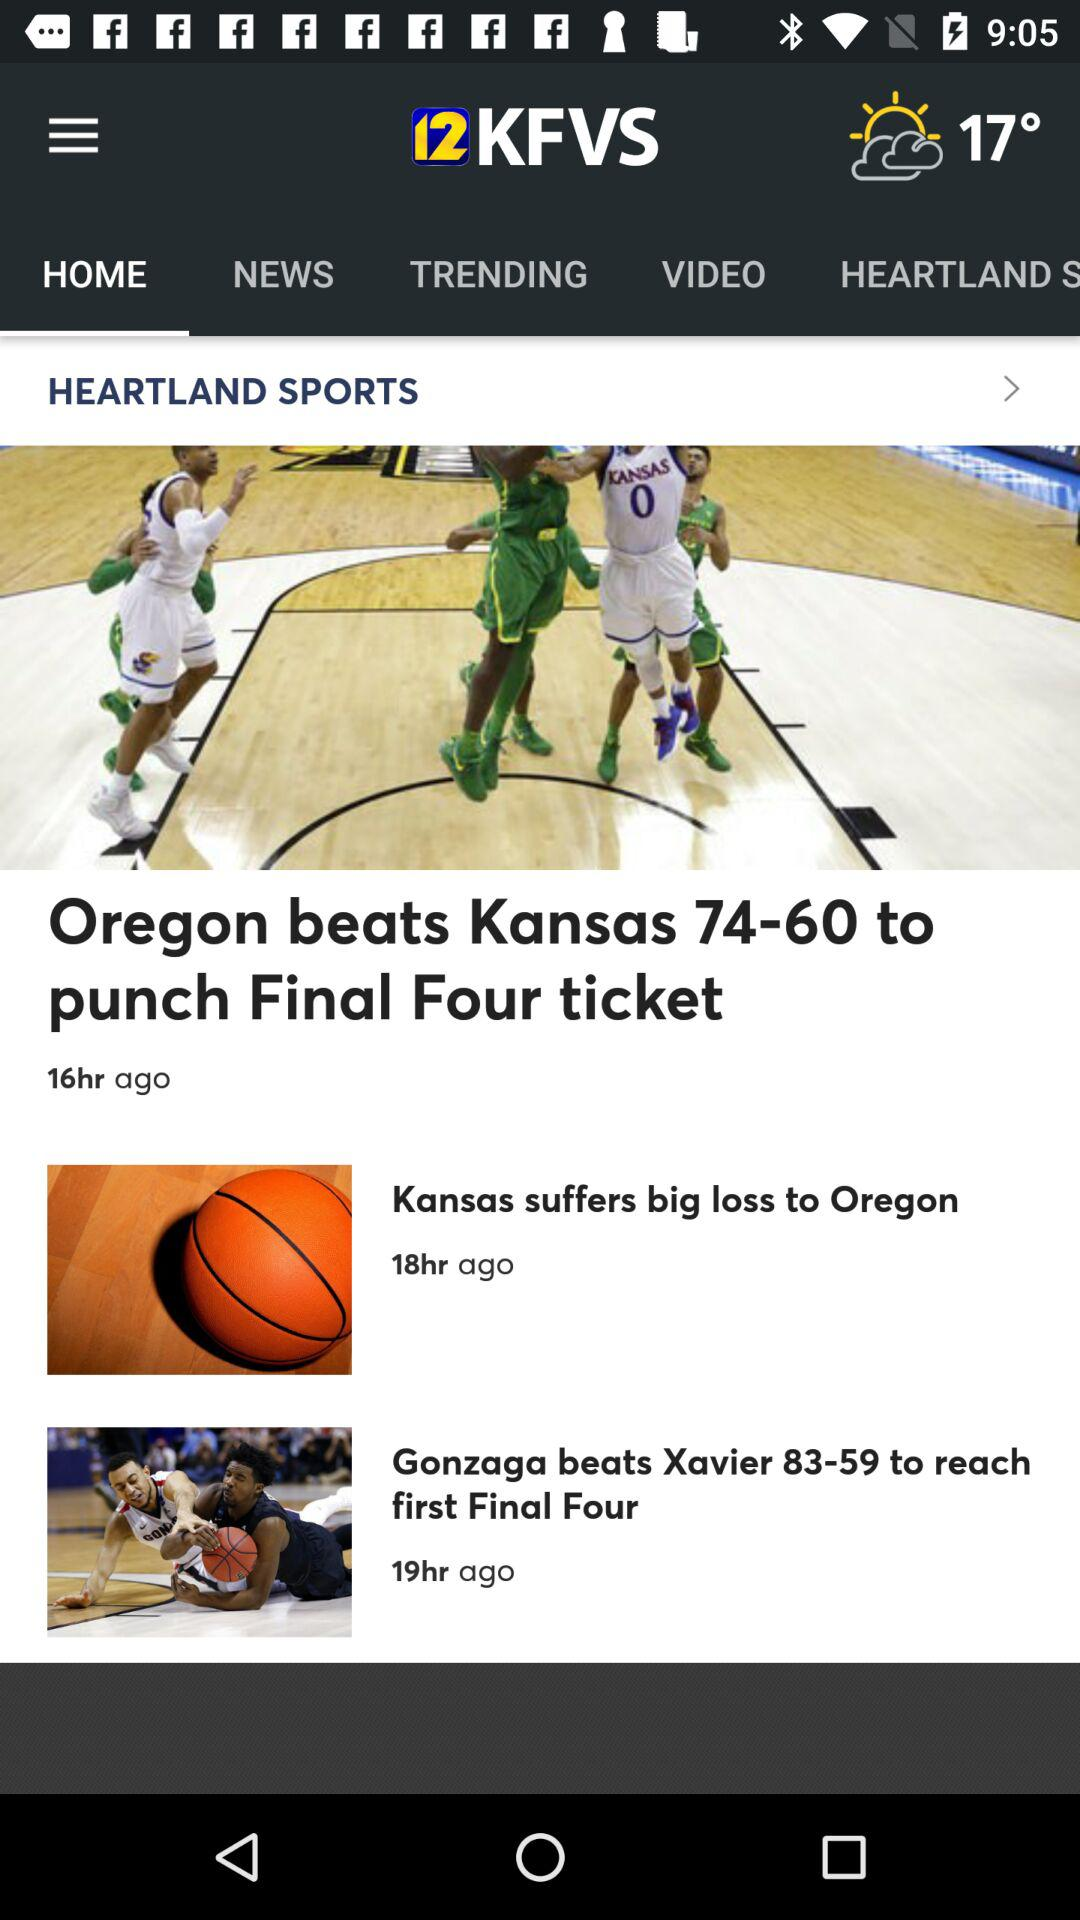What is the news channel name? The news channel name is "12 KFVS". 